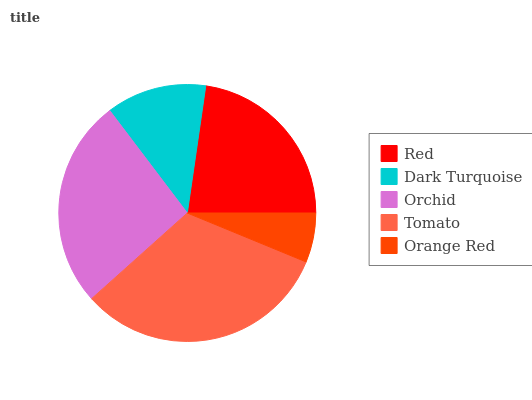Is Orange Red the minimum?
Answer yes or no. Yes. Is Tomato the maximum?
Answer yes or no. Yes. Is Dark Turquoise the minimum?
Answer yes or no. No. Is Dark Turquoise the maximum?
Answer yes or no. No. Is Red greater than Dark Turquoise?
Answer yes or no. Yes. Is Dark Turquoise less than Red?
Answer yes or no. Yes. Is Dark Turquoise greater than Red?
Answer yes or no. No. Is Red less than Dark Turquoise?
Answer yes or no. No. Is Red the high median?
Answer yes or no. Yes. Is Red the low median?
Answer yes or no. Yes. Is Tomato the high median?
Answer yes or no. No. Is Orchid the low median?
Answer yes or no. No. 